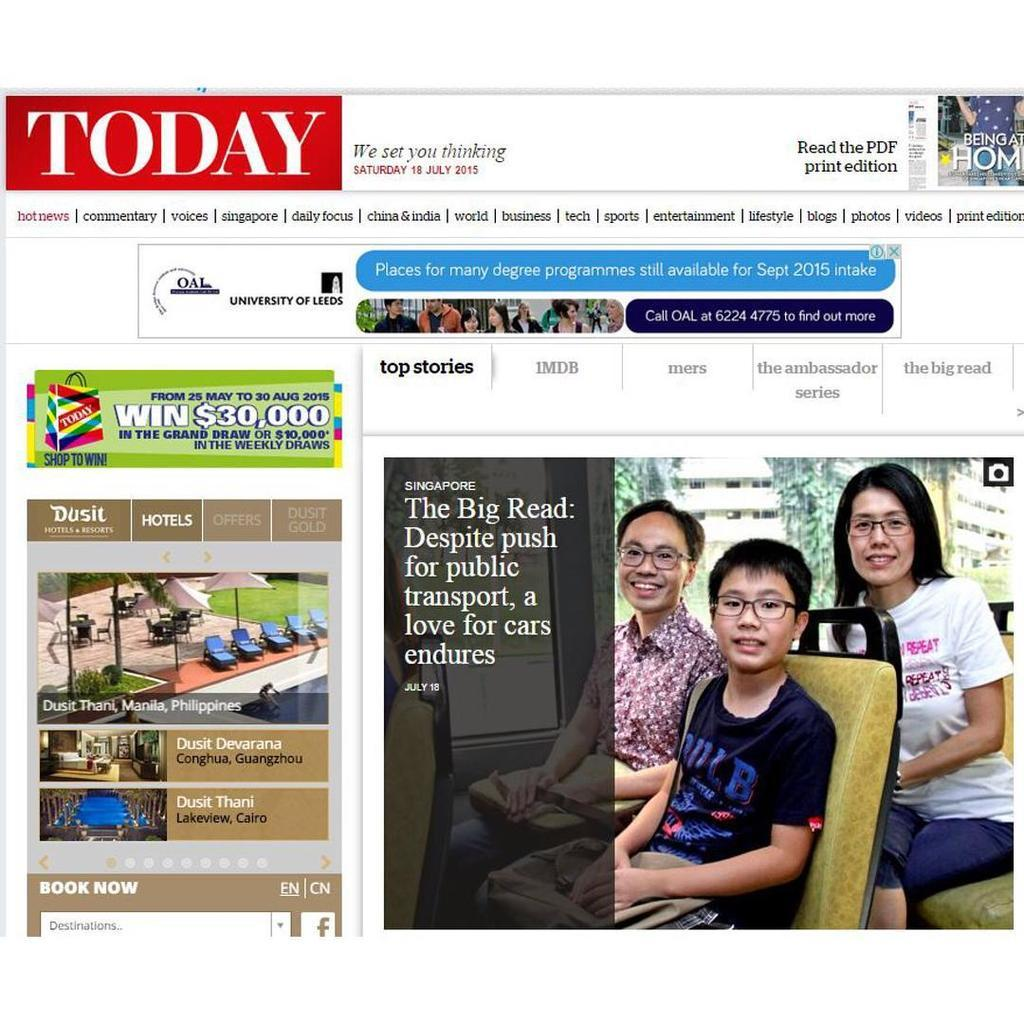<image>
Give a short and clear explanation of the subsequent image. A web page is titled Today and has a picture of people in glasses. 